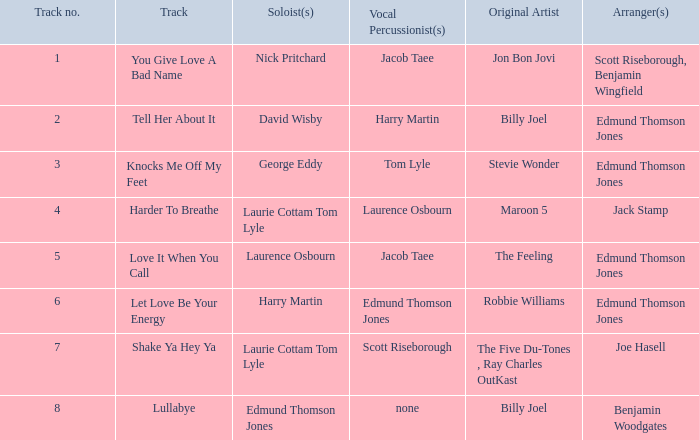Who arranged song(s) with tom lyle on the vocal percussion? Edmund Thomson Jones. 